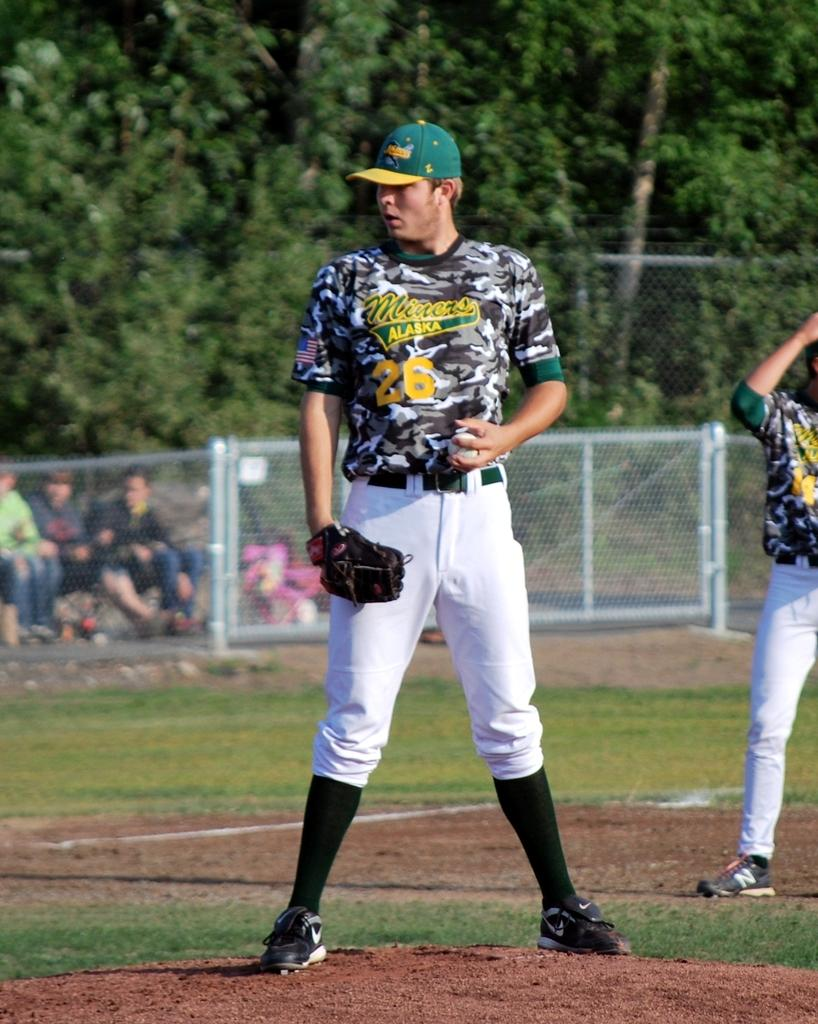<image>
Summarize the visual content of the image. A lefty pitcher for the Miners is on the mound ready to pitch. 